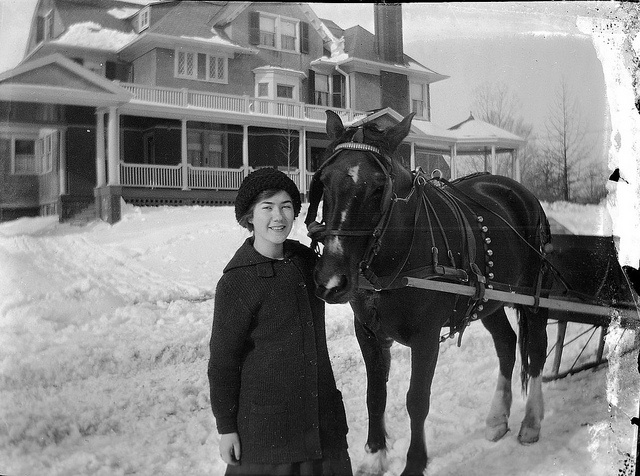Describe the objects in this image and their specific colors. I can see horse in lightgray, black, gray, and darkgray tones and people in lightgray, black, darkgray, and gray tones in this image. 